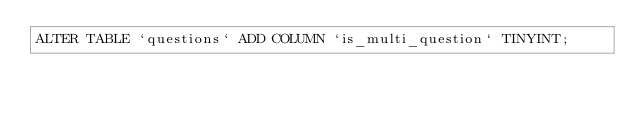Convert code to text. <code><loc_0><loc_0><loc_500><loc_500><_SQL_>ALTER TABLE `questions` ADD COLUMN `is_multi_question` TINYINT;</code> 